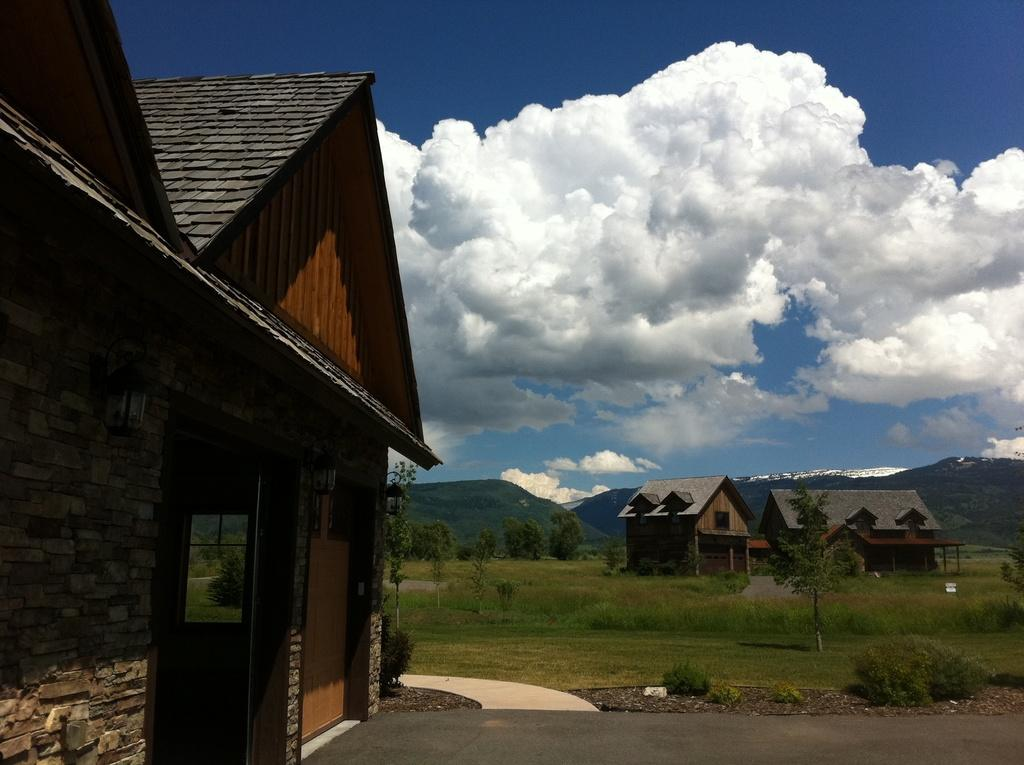What type of structures can be seen in the image? There are roofs of houses in the image. What type of natural features are present in the image? There are hills, trees, plants, and grass in the image. Is there a path visible in the image? Yes, there is a path in the image. What is visible in the background of the image? The sky is visible in the background of the image, with clouds present. Where is the shop located in the image? There is no shop present in the image. How many family members can be seen in the image? There is no family depicted in the image. 